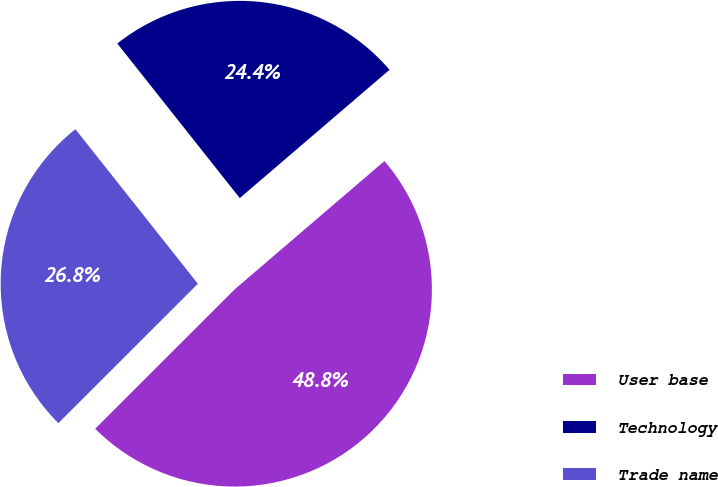Convert chart to OTSL. <chart><loc_0><loc_0><loc_500><loc_500><pie_chart><fcel>User base<fcel>Technology<fcel>Trade name<nl><fcel>48.78%<fcel>24.39%<fcel>26.83%<nl></chart> 